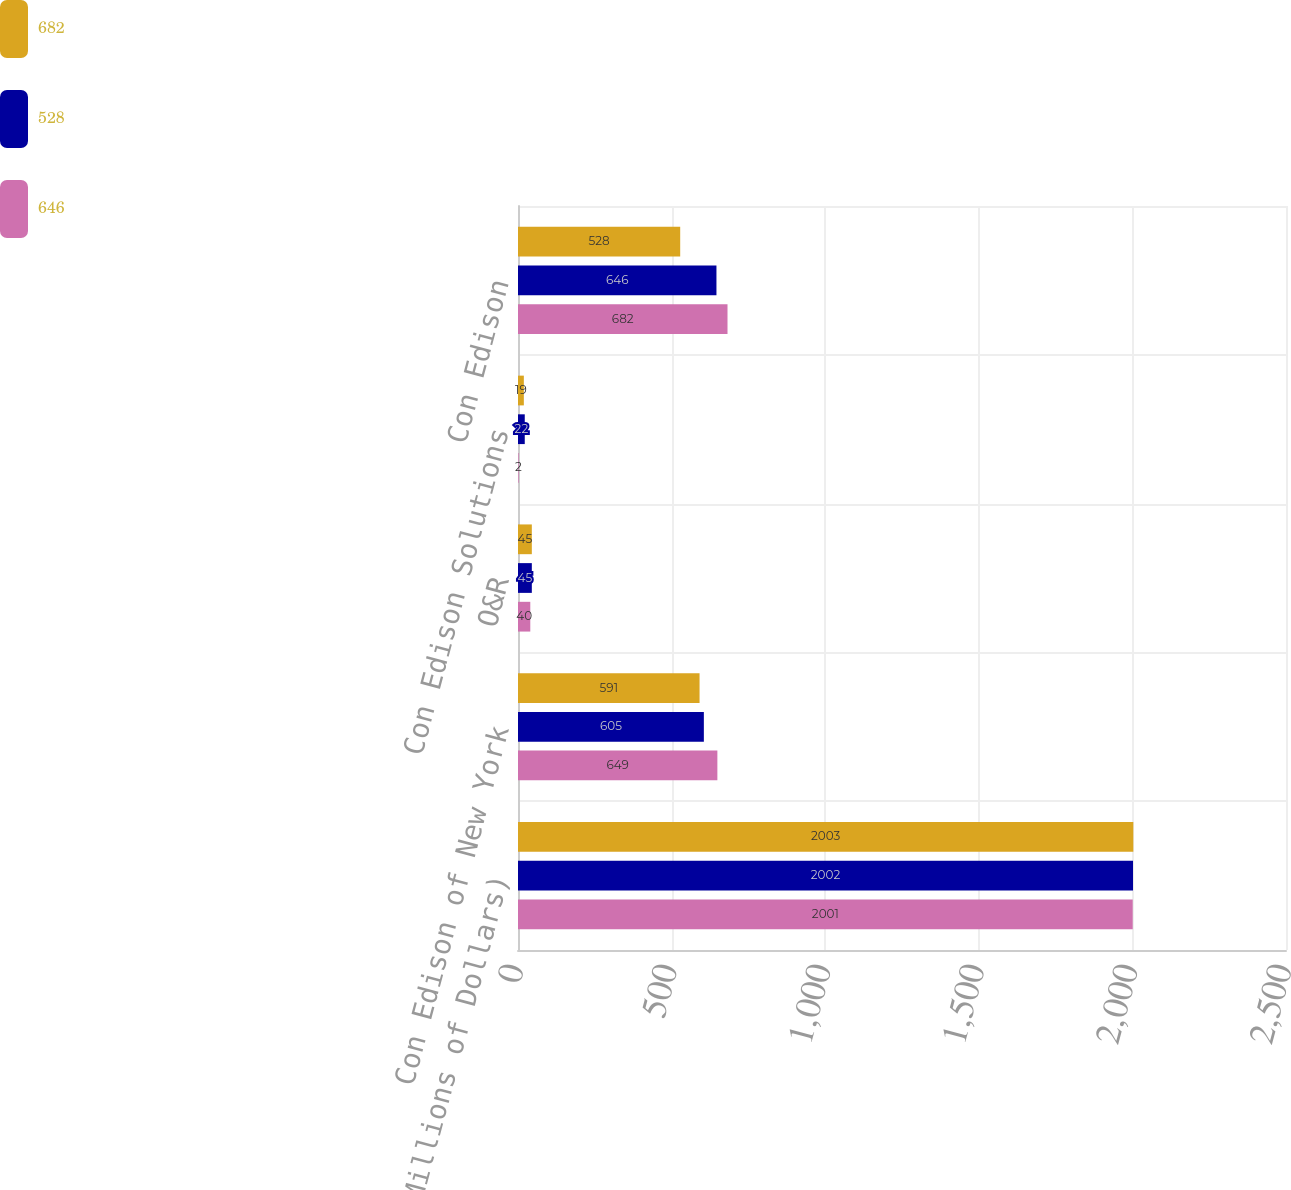<chart> <loc_0><loc_0><loc_500><loc_500><stacked_bar_chart><ecel><fcel>(Millions of Dollars)<fcel>Con Edison of New York<fcel>O&R<fcel>Con Edison Solutions<fcel>Con Edison<nl><fcel>682<fcel>2003<fcel>591<fcel>45<fcel>19<fcel>528<nl><fcel>528<fcel>2002<fcel>605<fcel>45<fcel>22<fcel>646<nl><fcel>646<fcel>2001<fcel>649<fcel>40<fcel>2<fcel>682<nl></chart> 